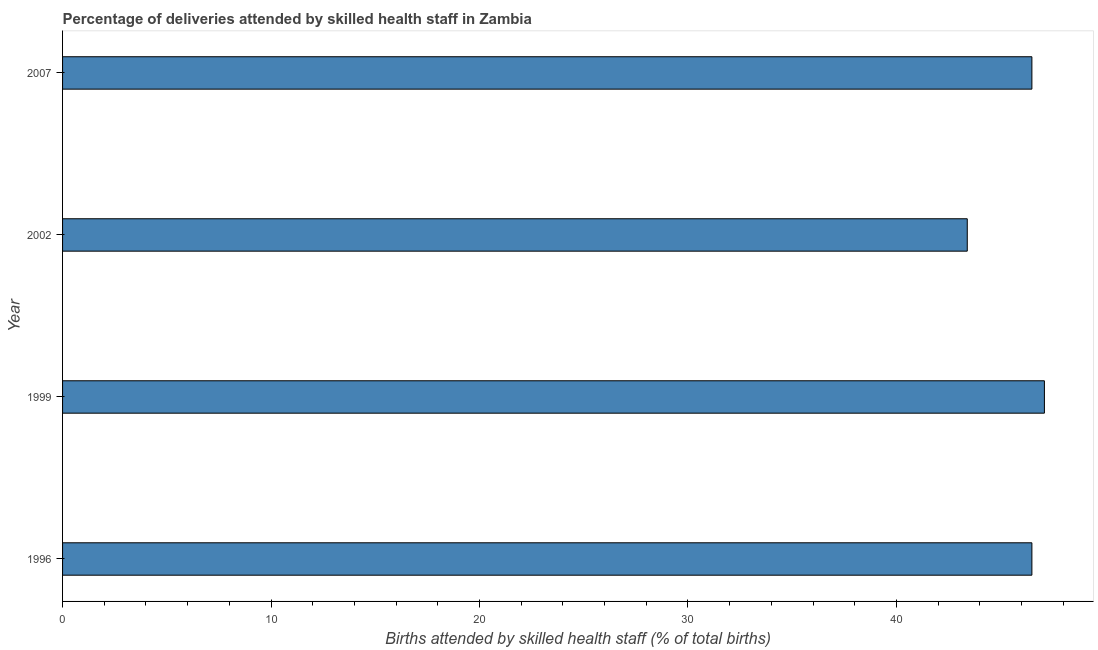Does the graph contain any zero values?
Ensure brevity in your answer.  No. Does the graph contain grids?
Offer a very short reply. No. What is the title of the graph?
Offer a very short reply. Percentage of deliveries attended by skilled health staff in Zambia. What is the label or title of the X-axis?
Your answer should be compact. Births attended by skilled health staff (% of total births). What is the label or title of the Y-axis?
Offer a terse response. Year. What is the number of births attended by skilled health staff in 2007?
Offer a very short reply. 46.5. Across all years, what is the maximum number of births attended by skilled health staff?
Offer a very short reply. 47.1. Across all years, what is the minimum number of births attended by skilled health staff?
Your answer should be compact. 43.4. In which year was the number of births attended by skilled health staff minimum?
Your answer should be compact. 2002. What is the sum of the number of births attended by skilled health staff?
Offer a terse response. 183.5. What is the difference between the number of births attended by skilled health staff in 1996 and 2002?
Offer a very short reply. 3.1. What is the average number of births attended by skilled health staff per year?
Your answer should be very brief. 45.88. What is the median number of births attended by skilled health staff?
Provide a succinct answer. 46.5. In how many years, is the number of births attended by skilled health staff greater than 14 %?
Your answer should be very brief. 4. Do a majority of the years between 1999 and 1996 (inclusive) have number of births attended by skilled health staff greater than 30 %?
Your response must be concise. No. What is the ratio of the number of births attended by skilled health staff in 2002 to that in 2007?
Provide a succinct answer. 0.93. Is the difference between the number of births attended by skilled health staff in 1999 and 2007 greater than the difference between any two years?
Offer a terse response. No. What is the difference between the highest and the second highest number of births attended by skilled health staff?
Ensure brevity in your answer.  0.6. How many bars are there?
Offer a very short reply. 4. Are all the bars in the graph horizontal?
Offer a very short reply. Yes. What is the difference between two consecutive major ticks on the X-axis?
Your response must be concise. 10. What is the Births attended by skilled health staff (% of total births) of 1996?
Ensure brevity in your answer.  46.5. What is the Births attended by skilled health staff (% of total births) in 1999?
Make the answer very short. 47.1. What is the Births attended by skilled health staff (% of total births) of 2002?
Give a very brief answer. 43.4. What is the Births attended by skilled health staff (% of total births) in 2007?
Offer a terse response. 46.5. What is the difference between the Births attended by skilled health staff (% of total births) in 1996 and 1999?
Provide a short and direct response. -0.6. What is the difference between the Births attended by skilled health staff (% of total births) in 1996 and 2007?
Your response must be concise. 0. What is the difference between the Births attended by skilled health staff (% of total births) in 1999 and 2007?
Give a very brief answer. 0.6. What is the ratio of the Births attended by skilled health staff (% of total births) in 1996 to that in 2002?
Offer a terse response. 1.07. What is the ratio of the Births attended by skilled health staff (% of total births) in 1999 to that in 2002?
Make the answer very short. 1.08. What is the ratio of the Births attended by skilled health staff (% of total births) in 2002 to that in 2007?
Your answer should be very brief. 0.93. 